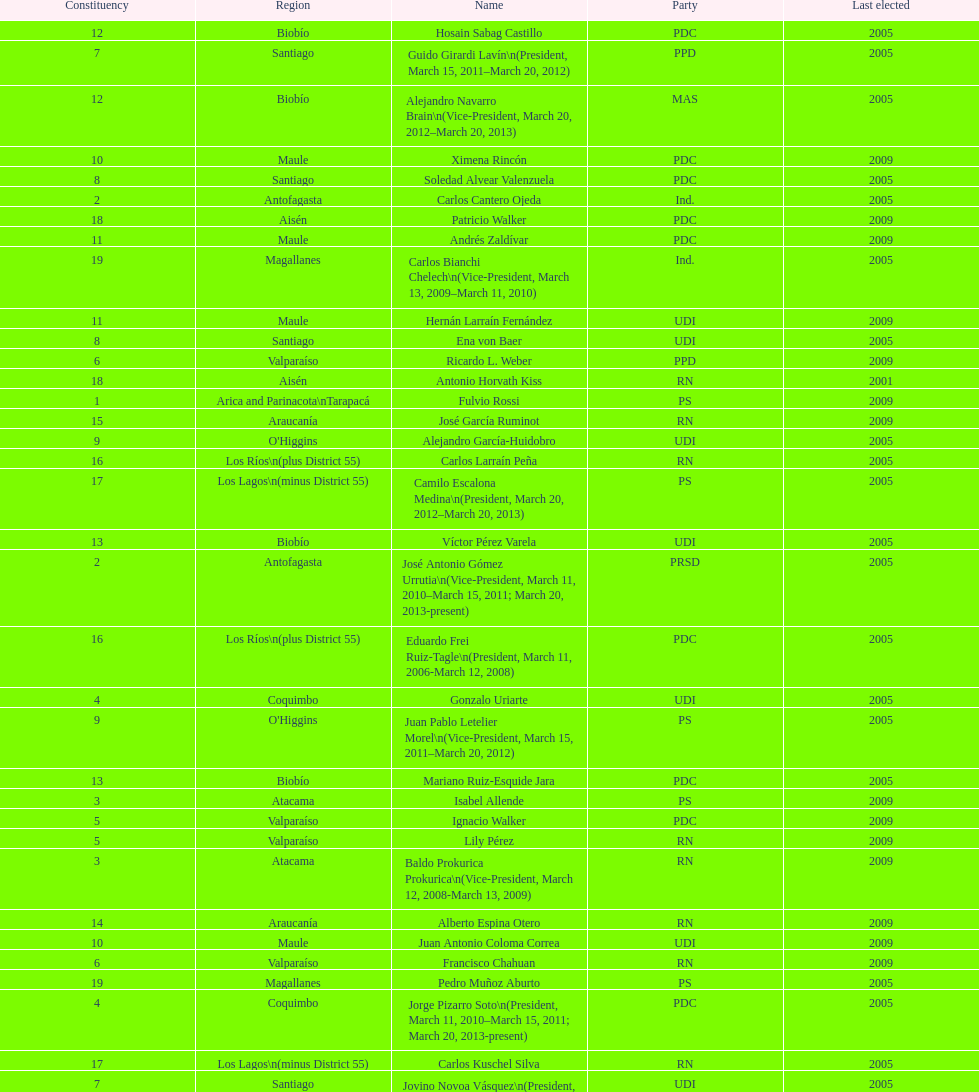When was antonio horvath kiss last elected? 2001. 